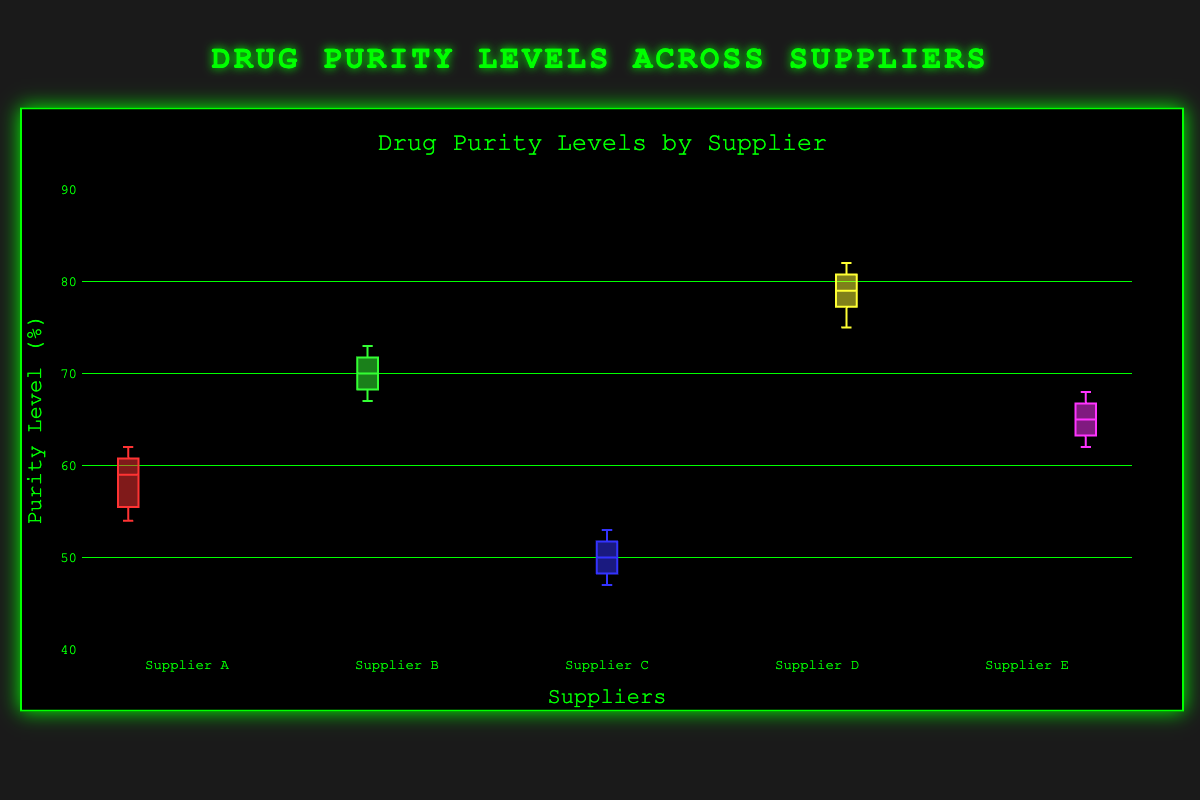What's the title of the figure? The title is at the top center of the figure, styled to stand out in uppercase letters.
Answer: Drug Purity Levels Across Suppliers Which supplier has the highest median purity level? The median can be seen as the central line in the box of each box plot. The box with the largest median line corresponds to Supplier D.
Answer: Supplier D What are the minimum and maximum purity levels for Supplier B? The minimum and maximum values are the ends of the whiskers for Supplier B's box plot. The minimum is 67, and the maximum is 73.
Answer: Minimum: 67, Maximum: 73 Compare the interquartile ranges (IQRs) of Supplier A and Supplier C. Which is larger? The IQR is the range between the first quartile (bottom of the box) and the third quartile (top of the box). Comparing the height of the boxes, Supplier A has a larger IQR than Supplier C.
Answer: Supplier A Which supplier has the smallest range of drug purity levels? The range is the difference between the maximum and minimum values. By comparing the lengths of the whiskers, Supplier E has the smallest range.
Answer: Supplier E What is the median purity level for Supplier E? The median is marked by the central line within the box. For Supplier E, this value is 65.
Answer: 65 How many data points are there for each supplier? Each box plot represents 7 data points, as stated in the data.
Answer: 7 Which supplier has the lowest median purity level? The median is the central line in the box. Supplier C has the lowest median line among the suppliers.
Answer: Supplier C Compare the median values of Supplier A and Supplier B. Which one is higher? The median values are represented by the central lines in the boxes. Supplier B’s median line is higher than Supplier A's.
Answer: Supplier B 